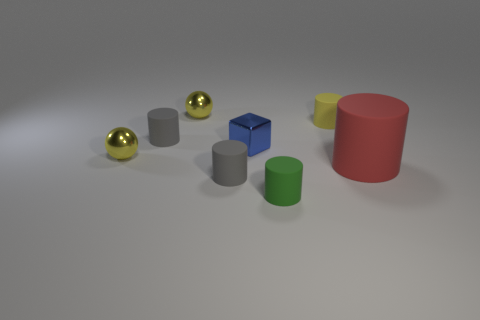How are the objects arranged in terms of size? The objects are arranged in no particular size order, but we can observe that the red cylinder is the largest, followed by the green cylinder, and then the blue cube. The gray cylinders appear smaller, and the gold spheres are the smallest. 